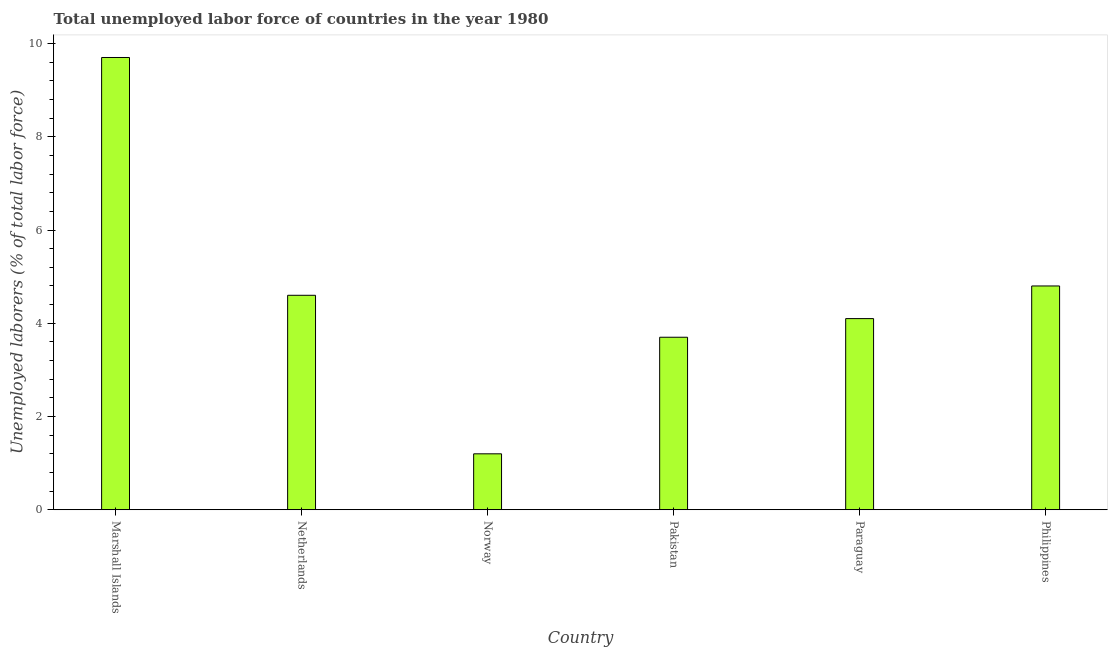What is the title of the graph?
Make the answer very short. Total unemployed labor force of countries in the year 1980. What is the label or title of the X-axis?
Your response must be concise. Country. What is the label or title of the Y-axis?
Offer a terse response. Unemployed laborers (% of total labor force). What is the total unemployed labour force in Paraguay?
Your answer should be very brief. 4.1. Across all countries, what is the maximum total unemployed labour force?
Offer a terse response. 9.7. Across all countries, what is the minimum total unemployed labour force?
Your response must be concise. 1.2. In which country was the total unemployed labour force maximum?
Make the answer very short. Marshall Islands. What is the sum of the total unemployed labour force?
Give a very brief answer. 28.1. What is the average total unemployed labour force per country?
Keep it short and to the point. 4.68. What is the median total unemployed labour force?
Make the answer very short. 4.35. In how many countries, is the total unemployed labour force greater than 8.8 %?
Your response must be concise. 1. Is the total unemployed labour force in Netherlands less than that in Pakistan?
Your answer should be compact. No. What is the difference between the highest and the second highest total unemployed labour force?
Provide a short and direct response. 4.9. Is the sum of the total unemployed labour force in Marshall Islands and Paraguay greater than the maximum total unemployed labour force across all countries?
Make the answer very short. Yes. What is the difference between the highest and the lowest total unemployed labour force?
Make the answer very short. 8.5. How many bars are there?
Your answer should be compact. 6. How many countries are there in the graph?
Provide a short and direct response. 6. What is the difference between two consecutive major ticks on the Y-axis?
Your answer should be very brief. 2. What is the Unemployed laborers (% of total labor force) of Marshall Islands?
Your answer should be compact. 9.7. What is the Unemployed laborers (% of total labor force) in Netherlands?
Make the answer very short. 4.6. What is the Unemployed laborers (% of total labor force) of Norway?
Offer a terse response. 1.2. What is the Unemployed laborers (% of total labor force) of Pakistan?
Your answer should be compact. 3.7. What is the Unemployed laborers (% of total labor force) of Paraguay?
Your answer should be very brief. 4.1. What is the Unemployed laborers (% of total labor force) of Philippines?
Provide a short and direct response. 4.8. What is the difference between the Unemployed laborers (% of total labor force) in Marshall Islands and Norway?
Offer a terse response. 8.5. What is the difference between the Unemployed laborers (% of total labor force) in Marshall Islands and Paraguay?
Your answer should be very brief. 5.6. What is the difference between the Unemployed laborers (% of total labor force) in Marshall Islands and Philippines?
Offer a terse response. 4.9. What is the difference between the Unemployed laborers (% of total labor force) in Netherlands and Norway?
Offer a very short reply. 3.4. What is the difference between the Unemployed laborers (% of total labor force) in Netherlands and Paraguay?
Offer a very short reply. 0.5. What is the difference between the Unemployed laborers (% of total labor force) in Norway and Pakistan?
Offer a terse response. -2.5. What is the difference between the Unemployed laborers (% of total labor force) in Norway and Paraguay?
Your answer should be compact. -2.9. What is the difference between the Unemployed laborers (% of total labor force) in Pakistan and Philippines?
Your response must be concise. -1.1. What is the ratio of the Unemployed laborers (% of total labor force) in Marshall Islands to that in Netherlands?
Offer a very short reply. 2.11. What is the ratio of the Unemployed laborers (% of total labor force) in Marshall Islands to that in Norway?
Give a very brief answer. 8.08. What is the ratio of the Unemployed laborers (% of total labor force) in Marshall Islands to that in Pakistan?
Your response must be concise. 2.62. What is the ratio of the Unemployed laborers (% of total labor force) in Marshall Islands to that in Paraguay?
Give a very brief answer. 2.37. What is the ratio of the Unemployed laborers (% of total labor force) in Marshall Islands to that in Philippines?
Your answer should be compact. 2.02. What is the ratio of the Unemployed laborers (% of total labor force) in Netherlands to that in Norway?
Make the answer very short. 3.83. What is the ratio of the Unemployed laborers (% of total labor force) in Netherlands to that in Pakistan?
Make the answer very short. 1.24. What is the ratio of the Unemployed laborers (% of total labor force) in Netherlands to that in Paraguay?
Offer a terse response. 1.12. What is the ratio of the Unemployed laborers (% of total labor force) in Netherlands to that in Philippines?
Provide a succinct answer. 0.96. What is the ratio of the Unemployed laborers (% of total labor force) in Norway to that in Pakistan?
Offer a terse response. 0.32. What is the ratio of the Unemployed laborers (% of total labor force) in Norway to that in Paraguay?
Make the answer very short. 0.29. What is the ratio of the Unemployed laborers (% of total labor force) in Pakistan to that in Paraguay?
Keep it short and to the point. 0.9. What is the ratio of the Unemployed laborers (% of total labor force) in Pakistan to that in Philippines?
Provide a short and direct response. 0.77. What is the ratio of the Unemployed laborers (% of total labor force) in Paraguay to that in Philippines?
Your answer should be compact. 0.85. 